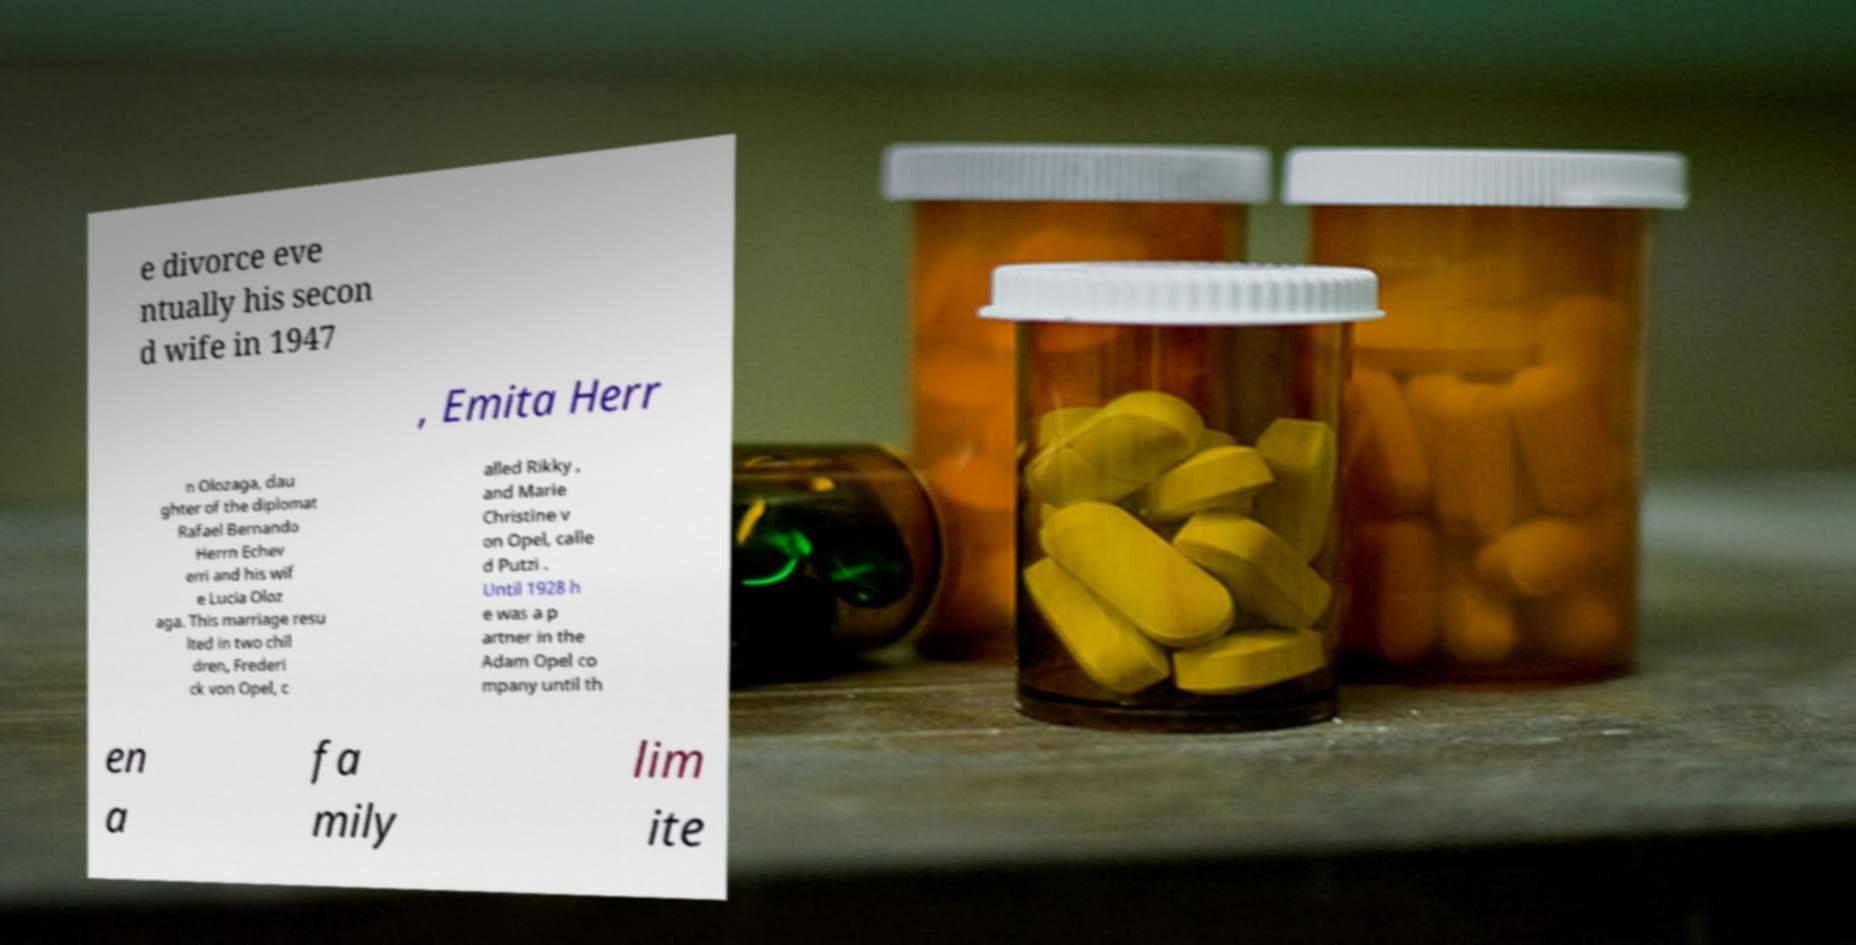Could you extract and type out the text from this image? e divorce eve ntually his secon d wife in 1947 , Emita Herr n Olozaga, dau ghter of the diplomat Rafael Bernando Herrn Echev erri and his wif e Lucia Oloz aga. This marriage resu lted in two chil dren, Frederi ck von Opel, c alled Rikky , and Marie Christine v on Opel, calle d Putzi . Until 1928 h e was a p artner in the Adam Opel co mpany until th en a fa mily lim ite 